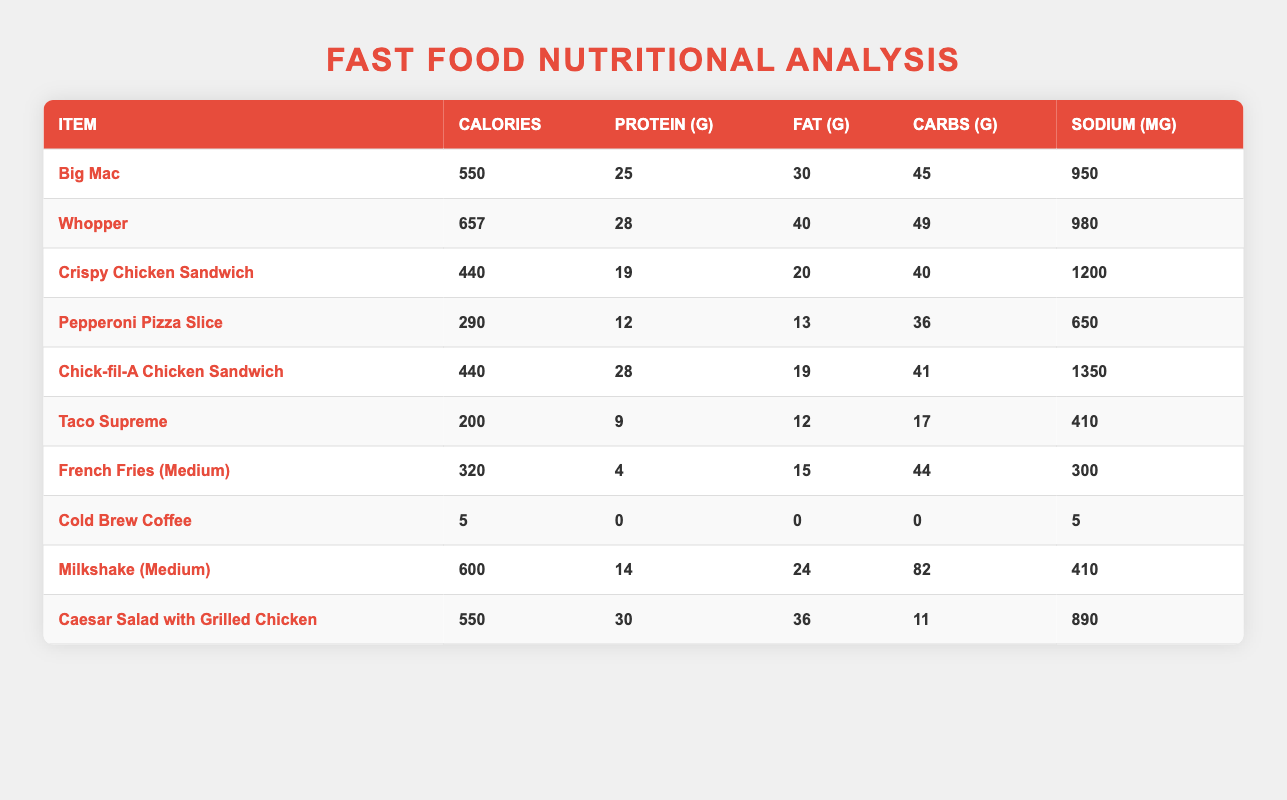What item has the highest calorie content? The Whopper has the highest calorie content at 657 calories, which can be identified by comparing the calorie values for each item in the table.
Answer: Whopper What is the protein content of the Big Mac? The protein content of the Big Mac is 25 grams, which is specified in the corresponding row under the protein column.
Answer: 25 grams How many grams of fat are in the Crispy Chicken Sandwich? The Crispy Chicken Sandwich contains 20 grams of fat, which is noted directly in the table under the fat column.
Answer: 20 grams What is the total number of calories for the Big Mac and the Caesar Salad combined? The total calories for the Big Mac (550) and the Caesar Salad with Grilled Chicken (550) is calculated as 550 + 550 = 1100 calories.
Answer: 1100 calories Is the sodium content of the Chick-fil-A Chicken Sandwich greater than that of the Taco Supreme? The sodium content in the Chick-fil-A Chicken Sandwich (1350 mg) is greater than that in the Taco Supreme (410 mg). This can be verified by comparing the sodium values in the table.
Answer: Yes What is the average carbohydrate content of the three items: French Fries, Milkshake, and Taco Supreme? The carbohydrate contents for the French Fries (44 g), Milkshake (82 g), and Taco Supreme (17 g) are summed to get 44 + 82 + 17 = 143 g. The average is then calculated as 143 g / 3 = 47.67 g.
Answer: 47.67 grams How many items have more than 600 mg of sodium? By reviewing the sodium values, the items with more than 600 mg of sodium are the Whopper, Crispy Chicken Sandwich, Chick-fil-A Chicken Sandwich, and Caesar Salad with Grilled Chicken, totaling 4 items.
Answer: 4 items Which item has the lowest protein content? The Taco Supreme is the item with the lowest protein content at 9 grams, as indicated in the protein column of the table.
Answer: Taco Supreme What is the difference in fat content between the Whopper and the Big Mac? The fat content of the Whopper (40 g) minus the fat content of the Big Mac (30 g) equals a difference of 10 grams.
Answer: 10 grams Which item has the highest sodium content? The Chick-fil-A Chicken Sandwich has the highest sodium content at 1350 mg, which can be determined by examining the sodium column in the table.
Answer: Chick-fil-A Chicken Sandwich 